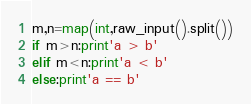Convert code to text. <code><loc_0><loc_0><loc_500><loc_500><_Python_>m,n=map(int,raw_input().split())
if m>n:print'a > b'
elif m<n:print'a < b'
else:print'a == b'</code> 